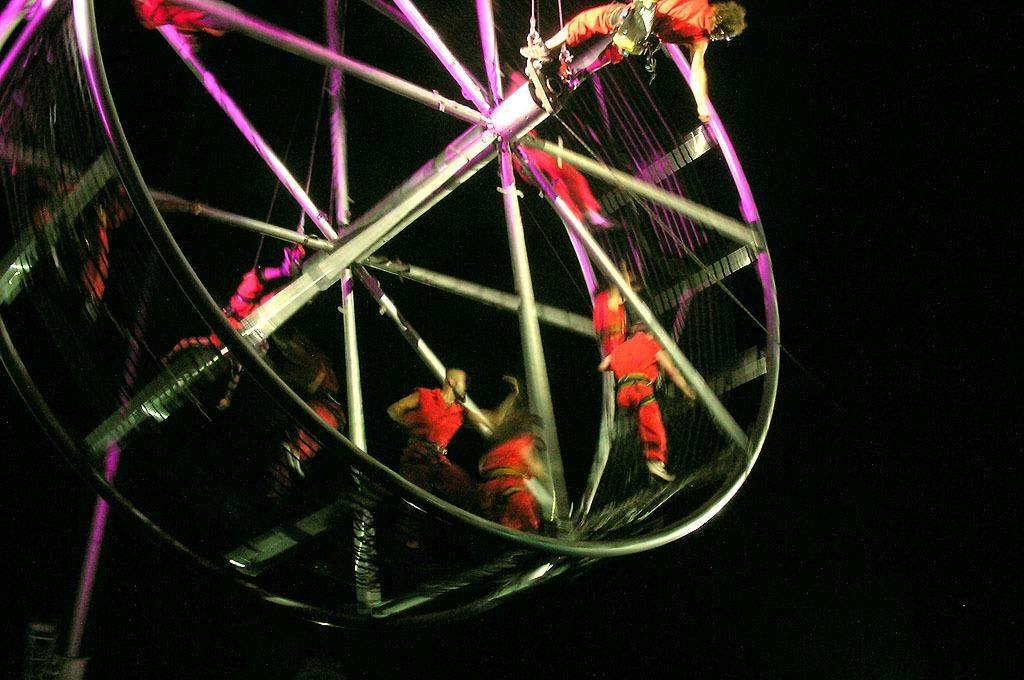What is the main object in the image? There is a wheel in the image. What is happening with the wheel? There are people on the wheel. What are the people wearing? The people are wearing red dresses. Where is the crate located in the image? There is no crate present in the image. What type of headwear is the person wearing in the image? The provided facts do not mention any headwear, so it cannot be determined from the image. 